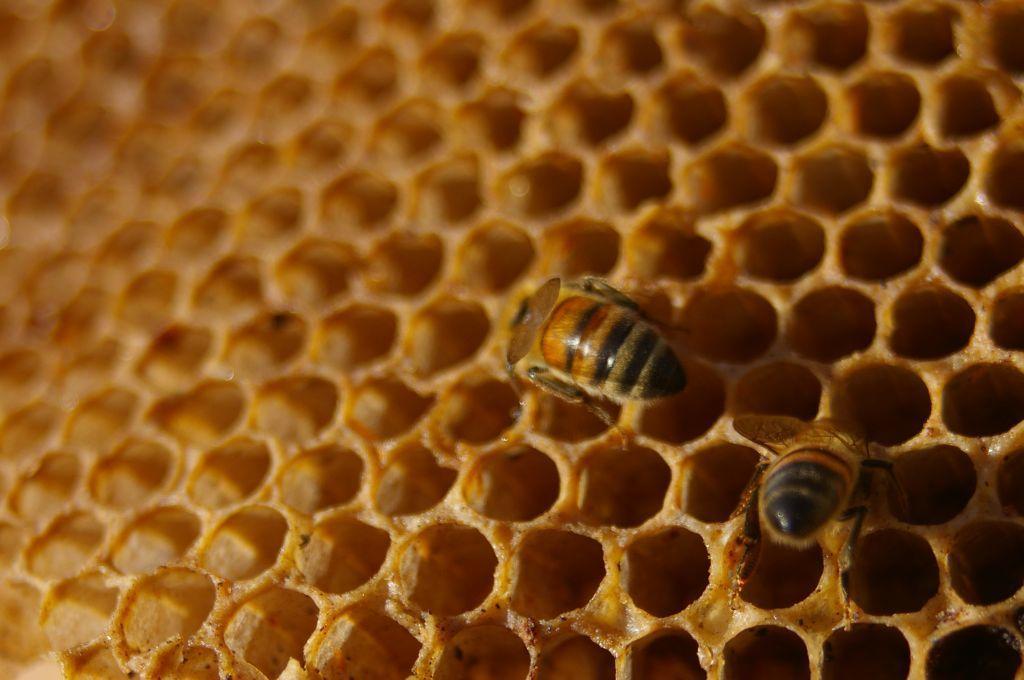Describe this image in one or two sentences. In this image there is a honey bee hive, in that there are two honey bees. 